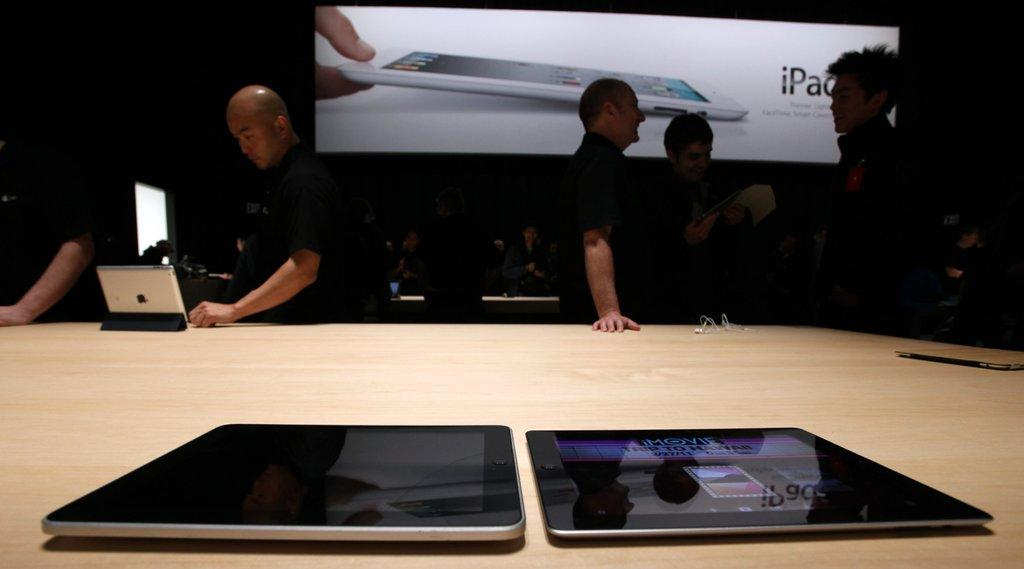What electronic devices are on the table in the image? There are two iPads on a table in the image. How many men are standing in the image? There are four men standing in the image. Can you describe the facial expression of one of the men? One of the men is laughing. What can be seen in the background of the image? There is a screen visible in the background. How many cacti are present on the table with the iPads? There are no cacti present on the table with the iPads; only the iPads are visible. What type of match is being played in the background? There is no match being played in the background; only a screen is visible. 